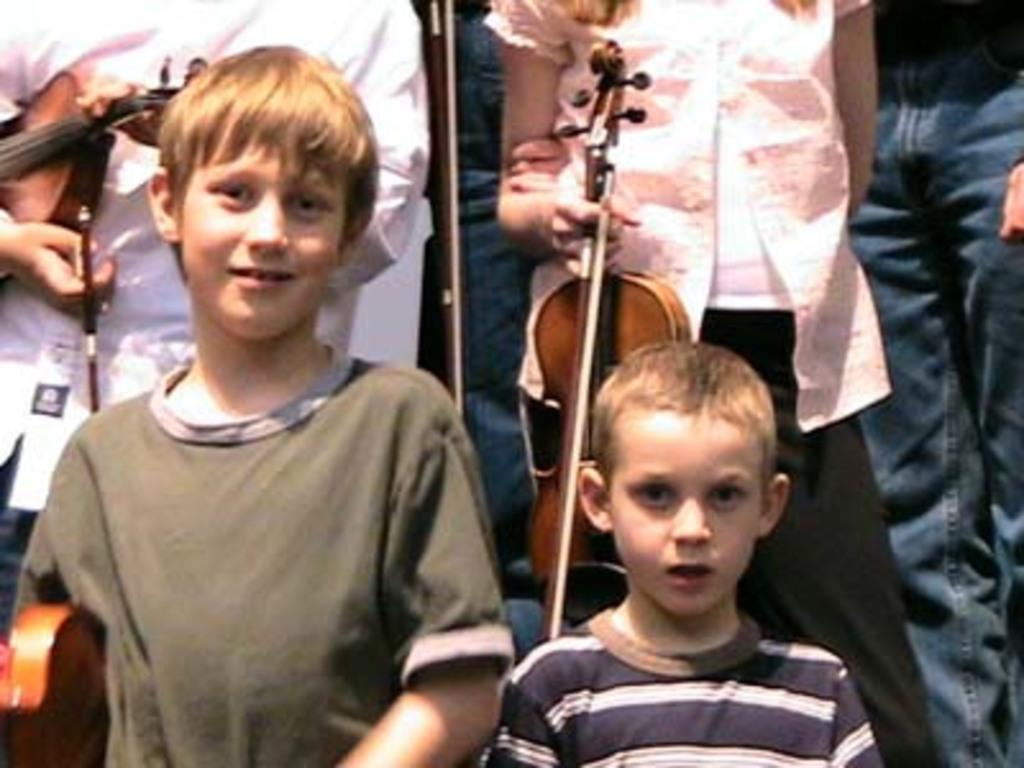How many kids are in the image? There are two kids standing in the image. What are the kids doing in the image? The kids are smiling. What can be seen in the background of the image? In the background of the image, there are people standing. What are the people in the background holding? The people in the background are holding music instruments. What is the color of the music instruments? The music instruments are yellow in color. Can you see any ears in the image? There is no mention of ears in the image, so we cannot determine if any are present. 